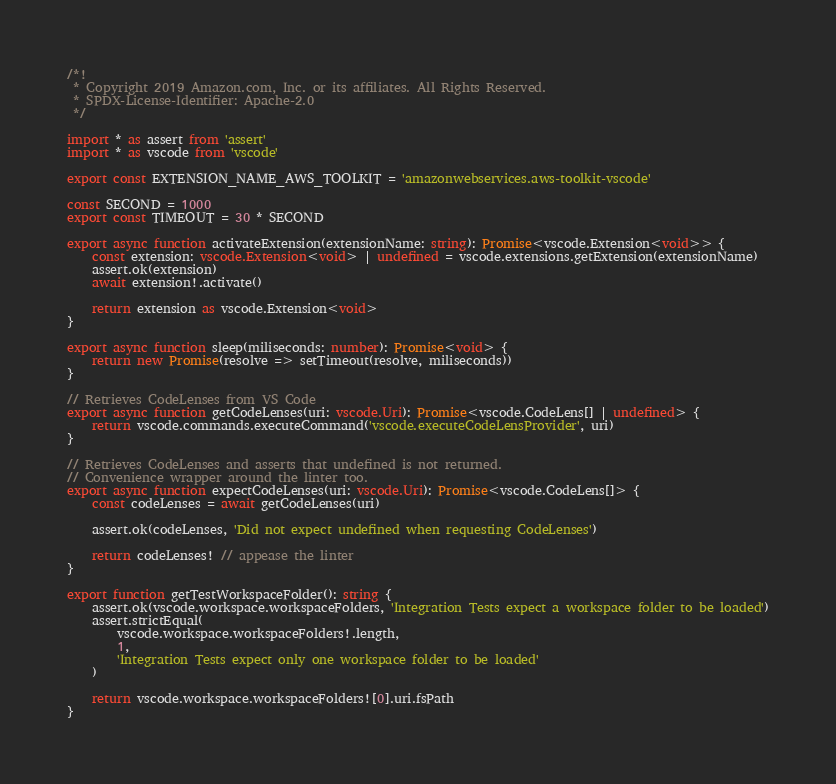Convert code to text. <code><loc_0><loc_0><loc_500><loc_500><_TypeScript_>/*!
 * Copyright 2019 Amazon.com, Inc. or its affiliates. All Rights Reserved.
 * SPDX-License-Identifier: Apache-2.0
 */

import * as assert from 'assert'
import * as vscode from 'vscode'

export const EXTENSION_NAME_AWS_TOOLKIT = 'amazonwebservices.aws-toolkit-vscode'

const SECOND = 1000
export const TIMEOUT = 30 * SECOND

export async function activateExtension(extensionName: string): Promise<vscode.Extension<void>> {
    const extension: vscode.Extension<void> | undefined = vscode.extensions.getExtension(extensionName)
    assert.ok(extension)
    await extension!.activate()

    return extension as vscode.Extension<void>
}

export async function sleep(miliseconds: number): Promise<void> {
    return new Promise(resolve => setTimeout(resolve, miliseconds))
}

// Retrieves CodeLenses from VS Code
export async function getCodeLenses(uri: vscode.Uri): Promise<vscode.CodeLens[] | undefined> {
    return vscode.commands.executeCommand('vscode.executeCodeLensProvider', uri)
}

// Retrieves CodeLenses and asserts that undefined is not returned.
// Convenience wrapper around the linter too.
export async function expectCodeLenses(uri: vscode.Uri): Promise<vscode.CodeLens[]> {
    const codeLenses = await getCodeLenses(uri)

    assert.ok(codeLenses, 'Did not expect undefined when requesting CodeLenses')

    return codeLenses! // appease the linter
}

export function getTestWorkspaceFolder(): string {
    assert.ok(vscode.workspace.workspaceFolders, 'Integration Tests expect a workspace folder to be loaded')
    assert.strictEqual(
        vscode.workspace.workspaceFolders!.length,
        1,
        'Integration Tests expect only one workspace folder to be loaded'
    )

    return vscode.workspace.workspaceFolders![0].uri.fsPath
}
</code> 